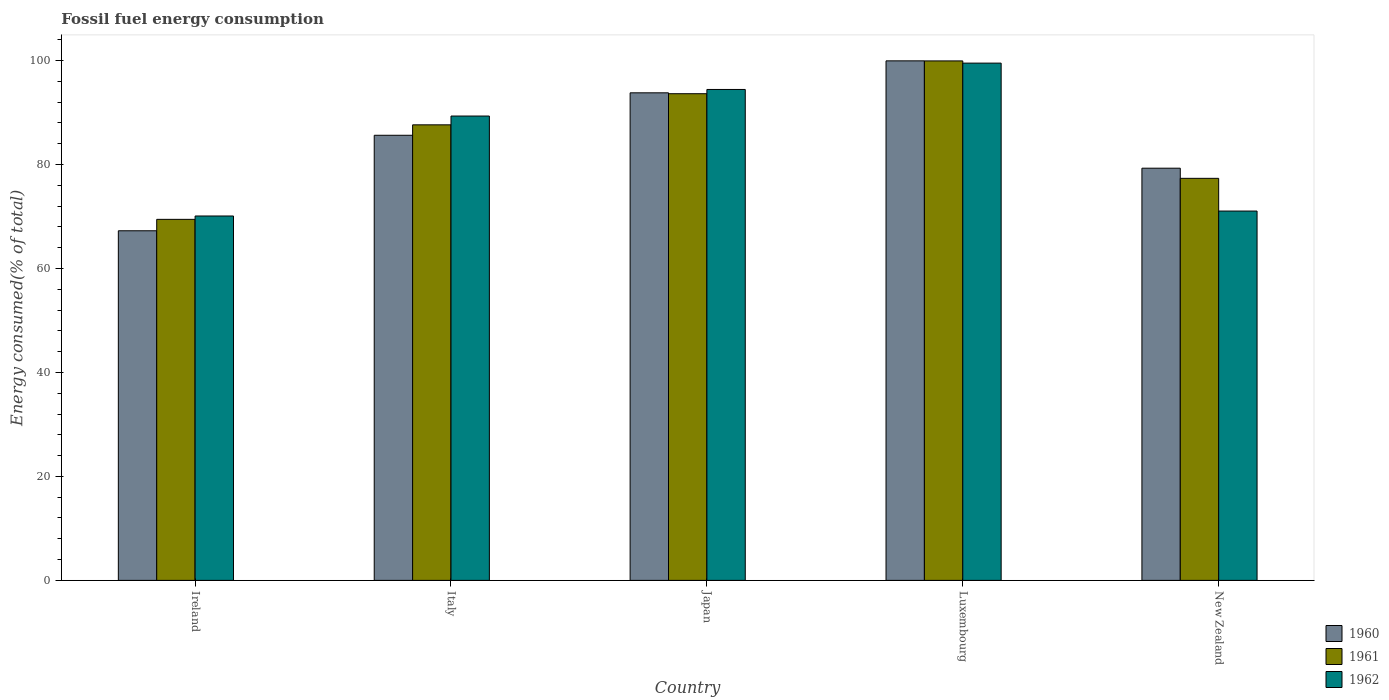How many different coloured bars are there?
Keep it short and to the point. 3. Are the number of bars per tick equal to the number of legend labels?
Give a very brief answer. Yes. Are the number of bars on each tick of the X-axis equal?
Provide a succinct answer. Yes. How many bars are there on the 2nd tick from the left?
Provide a short and direct response. 3. What is the label of the 5th group of bars from the left?
Give a very brief answer. New Zealand. What is the percentage of energy consumed in 1962 in Ireland?
Ensure brevity in your answer.  70.09. Across all countries, what is the maximum percentage of energy consumed in 1960?
Provide a succinct answer. 99.92. Across all countries, what is the minimum percentage of energy consumed in 1961?
Offer a very short reply. 69.44. In which country was the percentage of energy consumed in 1962 maximum?
Provide a short and direct response. Luxembourg. In which country was the percentage of energy consumed in 1961 minimum?
Provide a succinct answer. Ireland. What is the total percentage of energy consumed in 1961 in the graph?
Provide a short and direct response. 427.9. What is the difference between the percentage of energy consumed in 1962 in Ireland and that in New Zealand?
Your answer should be compact. -0.95. What is the difference between the percentage of energy consumed in 1960 in Ireland and the percentage of energy consumed in 1962 in Italy?
Ensure brevity in your answer.  -22.07. What is the average percentage of energy consumed in 1962 per country?
Ensure brevity in your answer.  84.87. What is the difference between the percentage of energy consumed of/in 1960 and percentage of energy consumed of/in 1962 in Ireland?
Make the answer very short. -2.84. What is the ratio of the percentage of energy consumed in 1961 in Italy to that in Japan?
Give a very brief answer. 0.94. Is the percentage of energy consumed in 1961 in Ireland less than that in New Zealand?
Offer a very short reply. Yes. What is the difference between the highest and the second highest percentage of energy consumed in 1962?
Make the answer very short. -10.18. What is the difference between the highest and the lowest percentage of energy consumed in 1961?
Offer a terse response. 30.47. What does the 2nd bar from the left in Japan represents?
Offer a very short reply. 1961. What does the 2nd bar from the right in Luxembourg represents?
Your answer should be compact. 1961. Is it the case that in every country, the sum of the percentage of energy consumed in 1962 and percentage of energy consumed in 1960 is greater than the percentage of energy consumed in 1961?
Keep it short and to the point. Yes. How many bars are there?
Ensure brevity in your answer.  15. Are all the bars in the graph horizontal?
Ensure brevity in your answer.  No. What is the difference between two consecutive major ticks on the Y-axis?
Your answer should be very brief. 20. How are the legend labels stacked?
Your answer should be compact. Vertical. What is the title of the graph?
Your response must be concise. Fossil fuel energy consumption. What is the label or title of the X-axis?
Ensure brevity in your answer.  Country. What is the label or title of the Y-axis?
Give a very brief answer. Energy consumed(% of total). What is the Energy consumed(% of total) of 1960 in Ireland?
Offer a terse response. 67.24. What is the Energy consumed(% of total) in 1961 in Ireland?
Keep it short and to the point. 69.44. What is the Energy consumed(% of total) of 1962 in Ireland?
Give a very brief answer. 70.09. What is the Energy consumed(% of total) of 1960 in Italy?
Make the answer very short. 85.61. What is the Energy consumed(% of total) of 1961 in Italy?
Your response must be concise. 87.62. What is the Energy consumed(% of total) in 1962 in Italy?
Provide a succinct answer. 89.31. What is the Energy consumed(% of total) in 1960 in Japan?
Your response must be concise. 93.78. What is the Energy consumed(% of total) of 1961 in Japan?
Your answer should be compact. 93.6. What is the Energy consumed(% of total) of 1962 in Japan?
Provide a succinct answer. 94.42. What is the Energy consumed(% of total) in 1960 in Luxembourg?
Your answer should be compact. 99.92. What is the Energy consumed(% of total) in 1961 in Luxembourg?
Your response must be concise. 99.91. What is the Energy consumed(% of total) in 1962 in Luxembourg?
Your answer should be very brief. 99.49. What is the Energy consumed(% of total) in 1960 in New Zealand?
Ensure brevity in your answer.  79.28. What is the Energy consumed(% of total) of 1961 in New Zealand?
Provide a short and direct response. 77.33. What is the Energy consumed(% of total) of 1962 in New Zealand?
Offer a very short reply. 71.04. Across all countries, what is the maximum Energy consumed(% of total) of 1960?
Keep it short and to the point. 99.92. Across all countries, what is the maximum Energy consumed(% of total) in 1961?
Offer a very short reply. 99.91. Across all countries, what is the maximum Energy consumed(% of total) in 1962?
Make the answer very short. 99.49. Across all countries, what is the minimum Energy consumed(% of total) in 1960?
Make the answer very short. 67.24. Across all countries, what is the minimum Energy consumed(% of total) of 1961?
Provide a short and direct response. 69.44. Across all countries, what is the minimum Energy consumed(% of total) in 1962?
Ensure brevity in your answer.  70.09. What is the total Energy consumed(% of total) in 1960 in the graph?
Offer a terse response. 425.83. What is the total Energy consumed(% of total) of 1961 in the graph?
Offer a terse response. 427.9. What is the total Energy consumed(% of total) of 1962 in the graph?
Ensure brevity in your answer.  424.34. What is the difference between the Energy consumed(% of total) in 1960 in Ireland and that in Italy?
Your answer should be compact. -18.37. What is the difference between the Energy consumed(% of total) of 1961 in Ireland and that in Italy?
Your answer should be compact. -18.18. What is the difference between the Energy consumed(% of total) of 1962 in Ireland and that in Italy?
Your answer should be very brief. -19.23. What is the difference between the Energy consumed(% of total) in 1960 in Ireland and that in Japan?
Your response must be concise. -26.53. What is the difference between the Energy consumed(% of total) of 1961 in Ireland and that in Japan?
Make the answer very short. -24.16. What is the difference between the Energy consumed(% of total) of 1962 in Ireland and that in Japan?
Make the answer very short. -24.34. What is the difference between the Energy consumed(% of total) of 1960 in Ireland and that in Luxembourg?
Your answer should be very brief. -32.68. What is the difference between the Energy consumed(% of total) in 1961 in Ireland and that in Luxembourg?
Your answer should be very brief. -30.47. What is the difference between the Energy consumed(% of total) in 1962 in Ireland and that in Luxembourg?
Provide a succinct answer. -29.4. What is the difference between the Energy consumed(% of total) of 1960 in Ireland and that in New Zealand?
Your response must be concise. -12.04. What is the difference between the Energy consumed(% of total) of 1961 in Ireland and that in New Zealand?
Ensure brevity in your answer.  -7.89. What is the difference between the Energy consumed(% of total) of 1962 in Ireland and that in New Zealand?
Make the answer very short. -0.95. What is the difference between the Energy consumed(% of total) in 1960 in Italy and that in Japan?
Keep it short and to the point. -8.17. What is the difference between the Energy consumed(% of total) in 1961 in Italy and that in Japan?
Give a very brief answer. -5.99. What is the difference between the Energy consumed(% of total) in 1962 in Italy and that in Japan?
Ensure brevity in your answer.  -5.11. What is the difference between the Energy consumed(% of total) of 1960 in Italy and that in Luxembourg?
Provide a succinct answer. -14.31. What is the difference between the Energy consumed(% of total) in 1961 in Italy and that in Luxembourg?
Provide a short and direct response. -12.3. What is the difference between the Energy consumed(% of total) in 1962 in Italy and that in Luxembourg?
Your response must be concise. -10.18. What is the difference between the Energy consumed(% of total) in 1960 in Italy and that in New Zealand?
Give a very brief answer. 6.33. What is the difference between the Energy consumed(% of total) in 1961 in Italy and that in New Zealand?
Ensure brevity in your answer.  10.29. What is the difference between the Energy consumed(% of total) in 1962 in Italy and that in New Zealand?
Make the answer very short. 18.27. What is the difference between the Energy consumed(% of total) of 1960 in Japan and that in Luxembourg?
Keep it short and to the point. -6.15. What is the difference between the Energy consumed(% of total) of 1961 in Japan and that in Luxembourg?
Your answer should be very brief. -6.31. What is the difference between the Energy consumed(% of total) in 1962 in Japan and that in Luxembourg?
Keep it short and to the point. -5.07. What is the difference between the Energy consumed(% of total) of 1960 in Japan and that in New Zealand?
Offer a terse response. 14.5. What is the difference between the Energy consumed(% of total) of 1961 in Japan and that in New Zealand?
Provide a short and direct response. 16.28. What is the difference between the Energy consumed(% of total) in 1962 in Japan and that in New Zealand?
Provide a short and direct response. 23.38. What is the difference between the Energy consumed(% of total) in 1960 in Luxembourg and that in New Zealand?
Your response must be concise. 20.65. What is the difference between the Energy consumed(% of total) in 1961 in Luxembourg and that in New Zealand?
Offer a terse response. 22.58. What is the difference between the Energy consumed(% of total) in 1962 in Luxembourg and that in New Zealand?
Offer a very short reply. 28.45. What is the difference between the Energy consumed(% of total) in 1960 in Ireland and the Energy consumed(% of total) in 1961 in Italy?
Ensure brevity in your answer.  -20.38. What is the difference between the Energy consumed(% of total) of 1960 in Ireland and the Energy consumed(% of total) of 1962 in Italy?
Provide a succinct answer. -22.07. What is the difference between the Energy consumed(% of total) in 1961 in Ireland and the Energy consumed(% of total) in 1962 in Italy?
Offer a terse response. -19.87. What is the difference between the Energy consumed(% of total) in 1960 in Ireland and the Energy consumed(% of total) in 1961 in Japan?
Offer a very short reply. -26.36. What is the difference between the Energy consumed(% of total) in 1960 in Ireland and the Energy consumed(% of total) in 1962 in Japan?
Keep it short and to the point. -27.18. What is the difference between the Energy consumed(% of total) of 1961 in Ireland and the Energy consumed(% of total) of 1962 in Japan?
Make the answer very short. -24.98. What is the difference between the Energy consumed(% of total) in 1960 in Ireland and the Energy consumed(% of total) in 1961 in Luxembourg?
Offer a terse response. -32.67. What is the difference between the Energy consumed(% of total) of 1960 in Ireland and the Energy consumed(% of total) of 1962 in Luxembourg?
Provide a short and direct response. -32.25. What is the difference between the Energy consumed(% of total) of 1961 in Ireland and the Energy consumed(% of total) of 1962 in Luxembourg?
Your answer should be compact. -30.05. What is the difference between the Energy consumed(% of total) of 1960 in Ireland and the Energy consumed(% of total) of 1961 in New Zealand?
Your answer should be compact. -10.09. What is the difference between the Energy consumed(% of total) in 1960 in Ireland and the Energy consumed(% of total) in 1962 in New Zealand?
Give a very brief answer. -3.79. What is the difference between the Energy consumed(% of total) of 1961 in Ireland and the Energy consumed(% of total) of 1962 in New Zealand?
Your response must be concise. -1.6. What is the difference between the Energy consumed(% of total) of 1960 in Italy and the Energy consumed(% of total) of 1961 in Japan?
Offer a very short reply. -7.99. What is the difference between the Energy consumed(% of total) of 1960 in Italy and the Energy consumed(% of total) of 1962 in Japan?
Provide a succinct answer. -8.81. What is the difference between the Energy consumed(% of total) of 1961 in Italy and the Energy consumed(% of total) of 1962 in Japan?
Keep it short and to the point. -6.8. What is the difference between the Energy consumed(% of total) in 1960 in Italy and the Energy consumed(% of total) in 1961 in Luxembourg?
Provide a short and direct response. -14.3. What is the difference between the Energy consumed(% of total) of 1960 in Italy and the Energy consumed(% of total) of 1962 in Luxembourg?
Ensure brevity in your answer.  -13.88. What is the difference between the Energy consumed(% of total) in 1961 in Italy and the Energy consumed(% of total) in 1962 in Luxembourg?
Provide a short and direct response. -11.87. What is the difference between the Energy consumed(% of total) in 1960 in Italy and the Energy consumed(% of total) in 1961 in New Zealand?
Provide a short and direct response. 8.28. What is the difference between the Energy consumed(% of total) in 1960 in Italy and the Energy consumed(% of total) in 1962 in New Zealand?
Offer a very short reply. 14.57. What is the difference between the Energy consumed(% of total) of 1961 in Italy and the Energy consumed(% of total) of 1962 in New Zealand?
Offer a terse response. 16.58. What is the difference between the Energy consumed(% of total) of 1960 in Japan and the Energy consumed(% of total) of 1961 in Luxembourg?
Give a very brief answer. -6.14. What is the difference between the Energy consumed(% of total) of 1960 in Japan and the Energy consumed(% of total) of 1962 in Luxembourg?
Offer a terse response. -5.71. What is the difference between the Energy consumed(% of total) in 1961 in Japan and the Energy consumed(% of total) in 1962 in Luxembourg?
Offer a very short reply. -5.88. What is the difference between the Energy consumed(% of total) of 1960 in Japan and the Energy consumed(% of total) of 1961 in New Zealand?
Your answer should be compact. 16.45. What is the difference between the Energy consumed(% of total) in 1960 in Japan and the Energy consumed(% of total) in 1962 in New Zealand?
Provide a succinct answer. 22.74. What is the difference between the Energy consumed(% of total) of 1961 in Japan and the Energy consumed(% of total) of 1962 in New Zealand?
Offer a very short reply. 22.57. What is the difference between the Energy consumed(% of total) of 1960 in Luxembourg and the Energy consumed(% of total) of 1961 in New Zealand?
Your answer should be very brief. 22.6. What is the difference between the Energy consumed(% of total) in 1960 in Luxembourg and the Energy consumed(% of total) in 1962 in New Zealand?
Provide a succinct answer. 28.89. What is the difference between the Energy consumed(% of total) of 1961 in Luxembourg and the Energy consumed(% of total) of 1962 in New Zealand?
Make the answer very short. 28.88. What is the average Energy consumed(% of total) of 1960 per country?
Your response must be concise. 85.17. What is the average Energy consumed(% of total) of 1961 per country?
Offer a very short reply. 85.58. What is the average Energy consumed(% of total) of 1962 per country?
Provide a succinct answer. 84.87. What is the difference between the Energy consumed(% of total) of 1960 and Energy consumed(% of total) of 1961 in Ireland?
Give a very brief answer. -2.2. What is the difference between the Energy consumed(% of total) of 1960 and Energy consumed(% of total) of 1962 in Ireland?
Provide a succinct answer. -2.84. What is the difference between the Energy consumed(% of total) of 1961 and Energy consumed(% of total) of 1962 in Ireland?
Offer a terse response. -0.65. What is the difference between the Energy consumed(% of total) in 1960 and Energy consumed(% of total) in 1961 in Italy?
Keep it short and to the point. -2.01. What is the difference between the Energy consumed(% of total) of 1960 and Energy consumed(% of total) of 1962 in Italy?
Give a very brief answer. -3.7. What is the difference between the Energy consumed(% of total) of 1961 and Energy consumed(% of total) of 1962 in Italy?
Make the answer very short. -1.69. What is the difference between the Energy consumed(% of total) in 1960 and Energy consumed(% of total) in 1961 in Japan?
Give a very brief answer. 0.17. What is the difference between the Energy consumed(% of total) of 1960 and Energy consumed(% of total) of 1962 in Japan?
Give a very brief answer. -0.64. What is the difference between the Energy consumed(% of total) of 1961 and Energy consumed(% of total) of 1962 in Japan?
Make the answer very short. -0.82. What is the difference between the Energy consumed(% of total) of 1960 and Energy consumed(% of total) of 1961 in Luxembourg?
Provide a succinct answer. 0.01. What is the difference between the Energy consumed(% of total) of 1960 and Energy consumed(% of total) of 1962 in Luxembourg?
Provide a succinct answer. 0.44. What is the difference between the Energy consumed(% of total) of 1961 and Energy consumed(% of total) of 1962 in Luxembourg?
Give a very brief answer. 0.42. What is the difference between the Energy consumed(% of total) in 1960 and Energy consumed(% of total) in 1961 in New Zealand?
Give a very brief answer. 1.95. What is the difference between the Energy consumed(% of total) in 1960 and Energy consumed(% of total) in 1962 in New Zealand?
Your answer should be compact. 8.24. What is the difference between the Energy consumed(% of total) in 1961 and Energy consumed(% of total) in 1962 in New Zealand?
Keep it short and to the point. 6.29. What is the ratio of the Energy consumed(% of total) of 1960 in Ireland to that in Italy?
Your answer should be very brief. 0.79. What is the ratio of the Energy consumed(% of total) of 1961 in Ireland to that in Italy?
Provide a short and direct response. 0.79. What is the ratio of the Energy consumed(% of total) of 1962 in Ireland to that in Italy?
Give a very brief answer. 0.78. What is the ratio of the Energy consumed(% of total) in 1960 in Ireland to that in Japan?
Make the answer very short. 0.72. What is the ratio of the Energy consumed(% of total) in 1961 in Ireland to that in Japan?
Give a very brief answer. 0.74. What is the ratio of the Energy consumed(% of total) in 1962 in Ireland to that in Japan?
Make the answer very short. 0.74. What is the ratio of the Energy consumed(% of total) in 1960 in Ireland to that in Luxembourg?
Your response must be concise. 0.67. What is the ratio of the Energy consumed(% of total) of 1961 in Ireland to that in Luxembourg?
Provide a short and direct response. 0.69. What is the ratio of the Energy consumed(% of total) in 1962 in Ireland to that in Luxembourg?
Your response must be concise. 0.7. What is the ratio of the Energy consumed(% of total) of 1960 in Ireland to that in New Zealand?
Ensure brevity in your answer.  0.85. What is the ratio of the Energy consumed(% of total) of 1961 in Ireland to that in New Zealand?
Ensure brevity in your answer.  0.9. What is the ratio of the Energy consumed(% of total) of 1962 in Ireland to that in New Zealand?
Your answer should be compact. 0.99. What is the ratio of the Energy consumed(% of total) in 1960 in Italy to that in Japan?
Make the answer very short. 0.91. What is the ratio of the Energy consumed(% of total) of 1961 in Italy to that in Japan?
Ensure brevity in your answer.  0.94. What is the ratio of the Energy consumed(% of total) in 1962 in Italy to that in Japan?
Keep it short and to the point. 0.95. What is the ratio of the Energy consumed(% of total) of 1960 in Italy to that in Luxembourg?
Offer a terse response. 0.86. What is the ratio of the Energy consumed(% of total) of 1961 in Italy to that in Luxembourg?
Offer a terse response. 0.88. What is the ratio of the Energy consumed(% of total) of 1962 in Italy to that in Luxembourg?
Offer a very short reply. 0.9. What is the ratio of the Energy consumed(% of total) of 1960 in Italy to that in New Zealand?
Give a very brief answer. 1.08. What is the ratio of the Energy consumed(% of total) of 1961 in Italy to that in New Zealand?
Your answer should be compact. 1.13. What is the ratio of the Energy consumed(% of total) of 1962 in Italy to that in New Zealand?
Provide a succinct answer. 1.26. What is the ratio of the Energy consumed(% of total) of 1960 in Japan to that in Luxembourg?
Ensure brevity in your answer.  0.94. What is the ratio of the Energy consumed(% of total) of 1961 in Japan to that in Luxembourg?
Your answer should be very brief. 0.94. What is the ratio of the Energy consumed(% of total) in 1962 in Japan to that in Luxembourg?
Make the answer very short. 0.95. What is the ratio of the Energy consumed(% of total) in 1960 in Japan to that in New Zealand?
Make the answer very short. 1.18. What is the ratio of the Energy consumed(% of total) of 1961 in Japan to that in New Zealand?
Your response must be concise. 1.21. What is the ratio of the Energy consumed(% of total) of 1962 in Japan to that in New Zealand?
Your answer should be very brief. 1.33. What is the ratio of the Energy consumed(% of total) in 1960 in Luxembourg to that in New Zealand?
Your response must be concise. 1.26. What is the ratio of the Energy consumed(% of total) of 1961 in Luxembourg to that in New Zealand?
Ensure brevity in your answer.  1.29. What is the ratio of the Energy consumed(% of total) in 1962 in Luxembourg to that in New Zealand?
Provide a succinct answer. 1.4. What is the difference between the highest and the second highest Energy consumed(% of total) in 1960?
Make the answer very short. 6.15. What is the difference between the highest and the second highest Energy consumed(% of total) in 1961?
Your answer should be very brief. 6.31. What is the difference between the highest and the second highest Energy consumed(% of total) in 1962?
Make the answer very short. 5.07. What is the difference between the highest and the lowest Energy consumed(% of total) of 1960?
Your answer should be very brief. 32.68. What is the difference between the highest and the lowest Energy consumed(% of total) in 1961?
Offer a terse response. 30.47. What is the difference between the highest and the lowest Energy consumed(% of total) in 1962?
Offer a terse response. 29.4. 